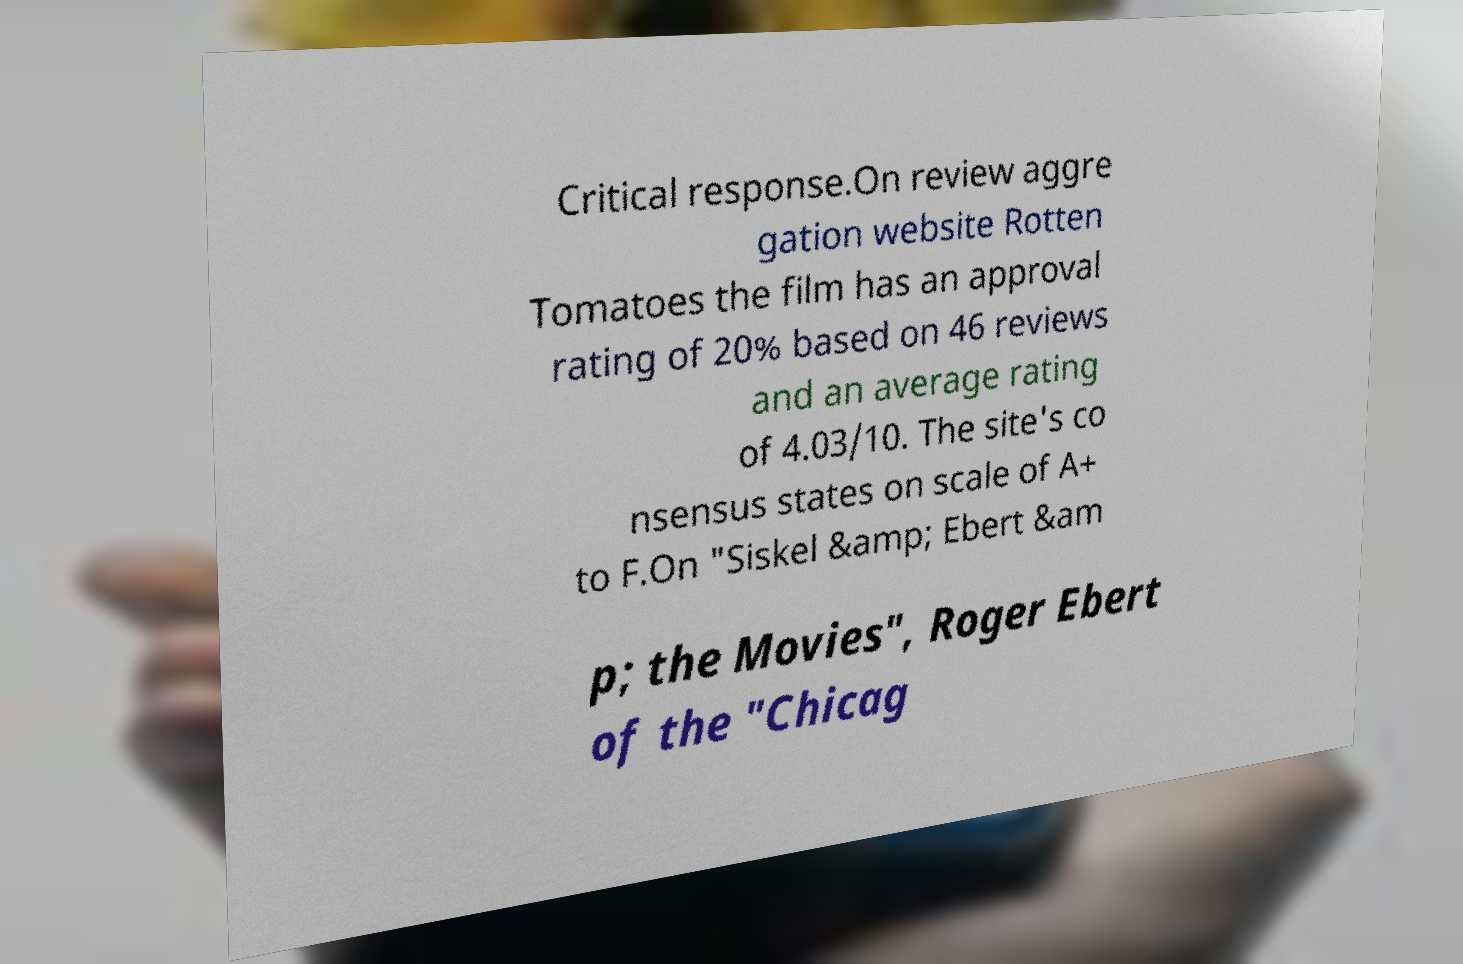Could you assist in decoding the text presented in this image and type it out clearly? Critical response.On review aggre gation website Rotten Tomatoes the film has an approval rating of 20% based on 46 reviews and an average rating of 4.03/10. The site's co nsensus states on scale of A+ to F.On "Siskel &amp; Ebert &am p; the Movies", Roger Ebert of the "Chicag 